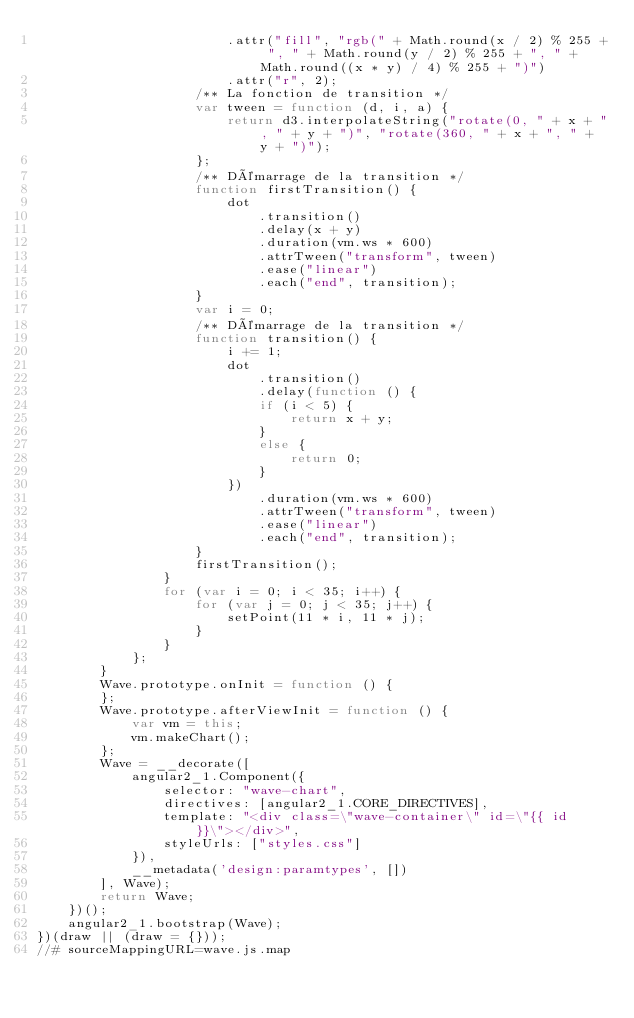<code> <loc_0><loc_0><loc_500><loc_500><_JavaScript_>                        .attr("fill", "rgb(" + Math.round(x / 2) % 255 + ", " + Math.round(y / 2) % 255 + ", " + Math.round((x * y) / 4) % 255 + ")")
                        .attr("r", 2);
                    /** La fonction de transition */
                    var tween = function (d, i, a) {
                        return d3.interpolateString("rotate(0, " + x + ", " + y + ")", "rotate(360, " + x + ", " + y + ")");
                    };
                    /** Démarrage de la transition */
                    function firstTransition() {
                        dot
                            .transition()
                            .delay(x + y)
                            .duration(vm.ws * 600)
                            .attrTween("transform", tween)
                            .ease("linear")
                            .each("end", transition);
                    }
                    var i = 0;
                    /** Démarrage de la transition */
                    function transition() {
                        i += 1;
                        dot
                            .transition()
                            .delay(function () {
                            if (i < 5) {
                                return x + y;
                            }
                            else {
                                return 0;
                            }
                        })
                            .duration(vm.ws * 600)
                            .attrTween("transform", tween)
                            .ease("linear")
                            .each("end", transition);
                    }
                    firstTransition();
                }
                for (var i = 0; i < 35; i++) {
                    for (var j = 0; j < 35; j++) {
                        setPoint(11 * i, 11 * j);
                    }
                }
            };
        }
        Wave.prototype.onInit = function () {
        };
        Wave.prototype.afterViewInit = function () {
            var vm = this;
            vm.makeChart();
        };
        Wave = __decorate([
            angular2_1.Component({
                selector: "wave-chart",
                directives: [angular2_1.CORE_DIRECTIVES],
                template: "<div class=\"wave-container\" id=\"{{ id }}\"></div>",
                styleUrls: ["styles.css"]
            }), 
            __metadata('design:paramtypes', [])
        ], Wave);
        return Wave;
    })();
    angular2_1.bootstrap(Wave);
})(draw || (draw = {}));
//# sourceMappingURL=wave.js.map</code> 